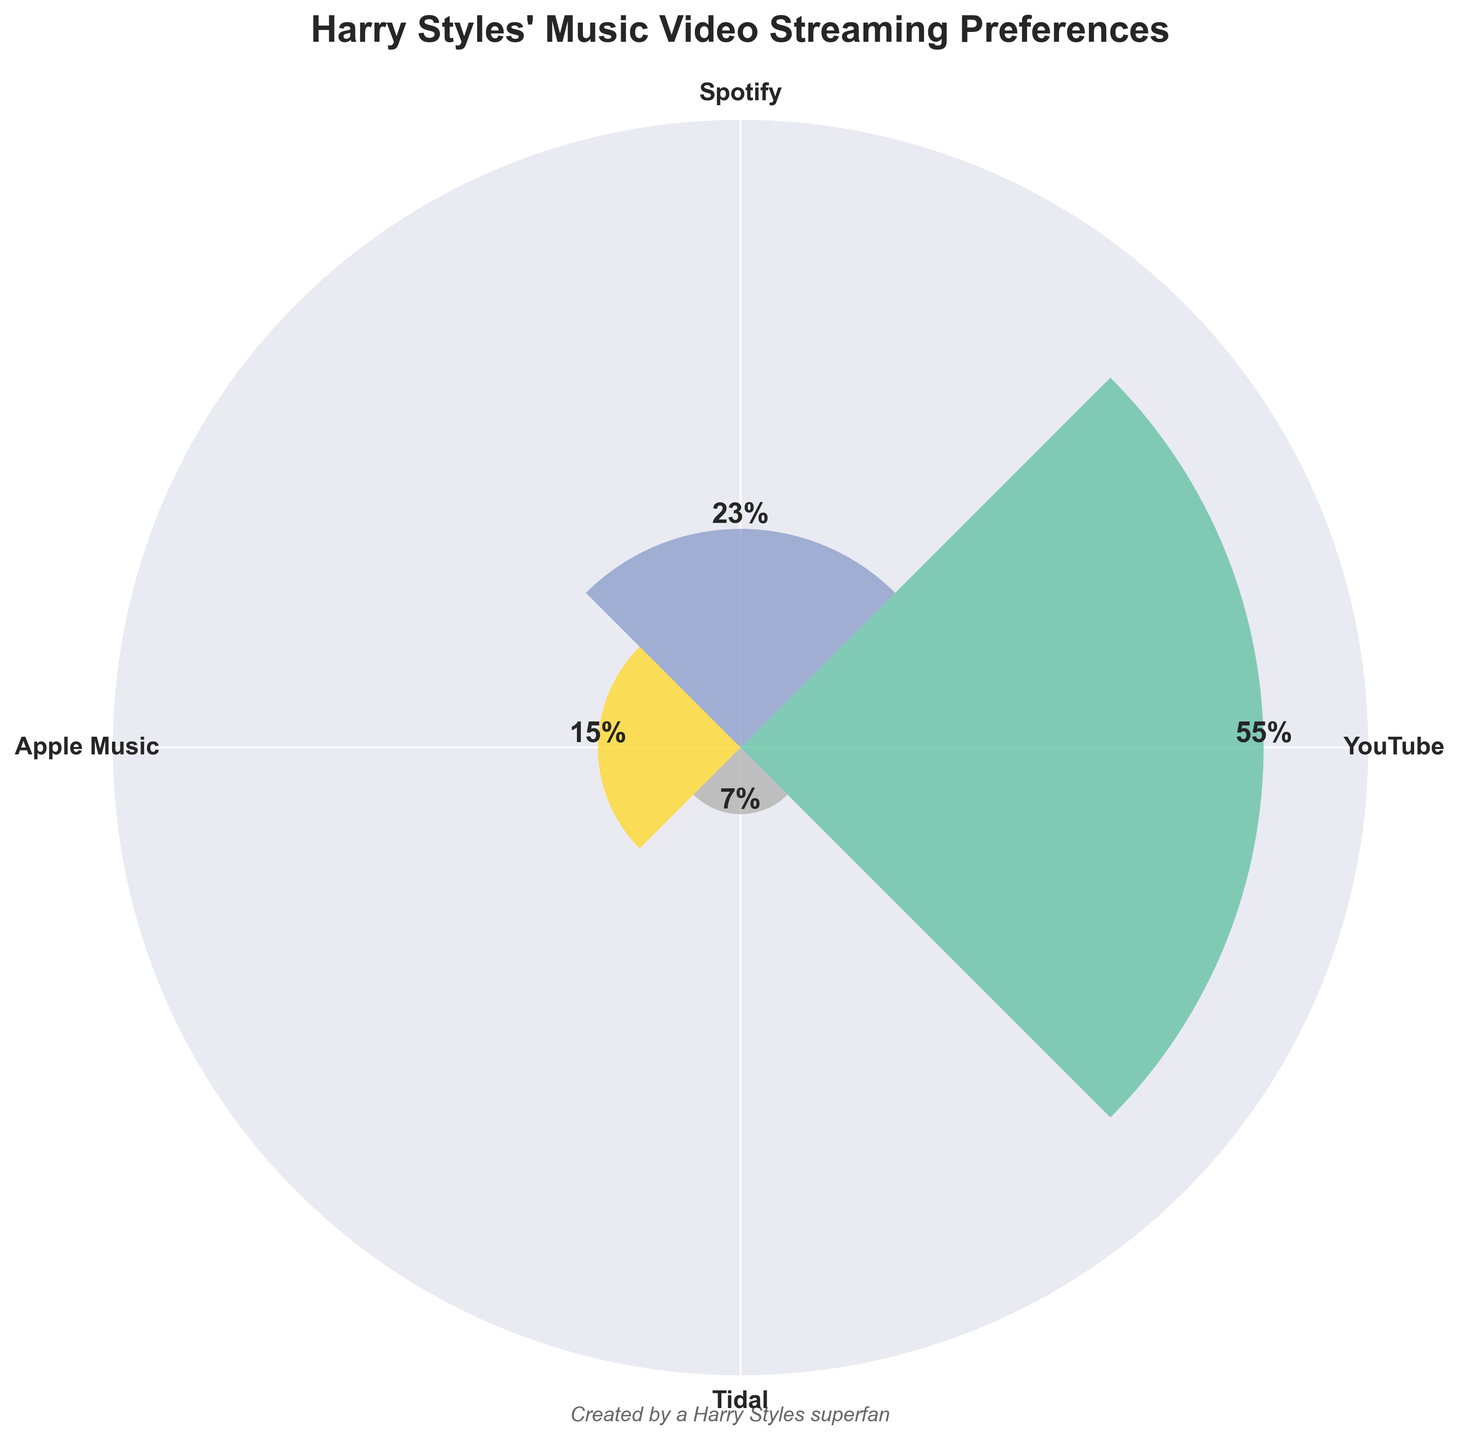How many platforms are visualized in the figure? Count the number of different platforms displayed around the rose chart. The figure shows four different platforms: YouTube, Spotify, Apple Music, and Tidal.
Answer: Four Which platform has the highest percentage for watching Harry Styles' music videos? Identify the bar with the greatest height on the rose chart. The highest bar is labeled YouTube, with a percentage of 55%.
Answer: YouTube What is the range of percentages displayed in the figure? Determine the difference between the largest and smallest percentage values. The largest is 55% (YouTube) and the smallest is 7% (Tidal). The range is 55 - 7 = 48.
Answer: 48 What is the percentage breakdown for Spotify? Find the bar labeled Spotify and read its corresponding value. The rose chart shows a bar for Spotify with a percentage of 23%.
Answer: 23% Which platform has the lowest percentage for watching Harry Styles' music videos? Identify the bar with the smallest height on the rose chart. The lowest bar is labeled Tidal, with a percentage of 7%.
Answer: Tidal How do the percentages of Apple Music and Spotify compare? Compare the heights and values of the bars for Apple Music and Spotify. Spotify has 23%, while Apple Music has 15%. Therefore, Spotify is higher than Apple Music.
Answer: Spotify > Apple Music Calculate the total percentage for platforms other than YouTube. Sum the percentages for the platforms Spotify, Apple Music, and Tidal. The values are 23% (Spotify) + 15% (Apple Music) + 7% (Tidal) = 45%.
Answer: 45% Which platform is twice as popular as Tidal in terms of percentage? Identify the bar whose percentage is approximately double that of Tidal (which is 7%). Apple Music has 15%, which is a little more than twice 7%.
Answer: Apple Music What is the average percentage of all the platforms? Sum all the percentages and divide by the number of platforms. The sum is 55% + 23% + 15% + 7% = 100%. There are four platforms, so the average is 100 / 4 = 25%.
Answer: 25% Which platform is less popular than Apple Music but more popular than Tidal? Identify bars that fit the criteria of having a percentage less than Apple Music (15%) and greater than Tidal (7%). Spotify fits this with a percentage of 23%.
Answer: Spotify 